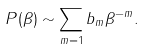<formula> <loc_0><loc_0><loc_500><loc_500>P ( \beta ) \sim \sum _ { m = 1 } b _ { m } \beta ^ { - m } .</formula> 